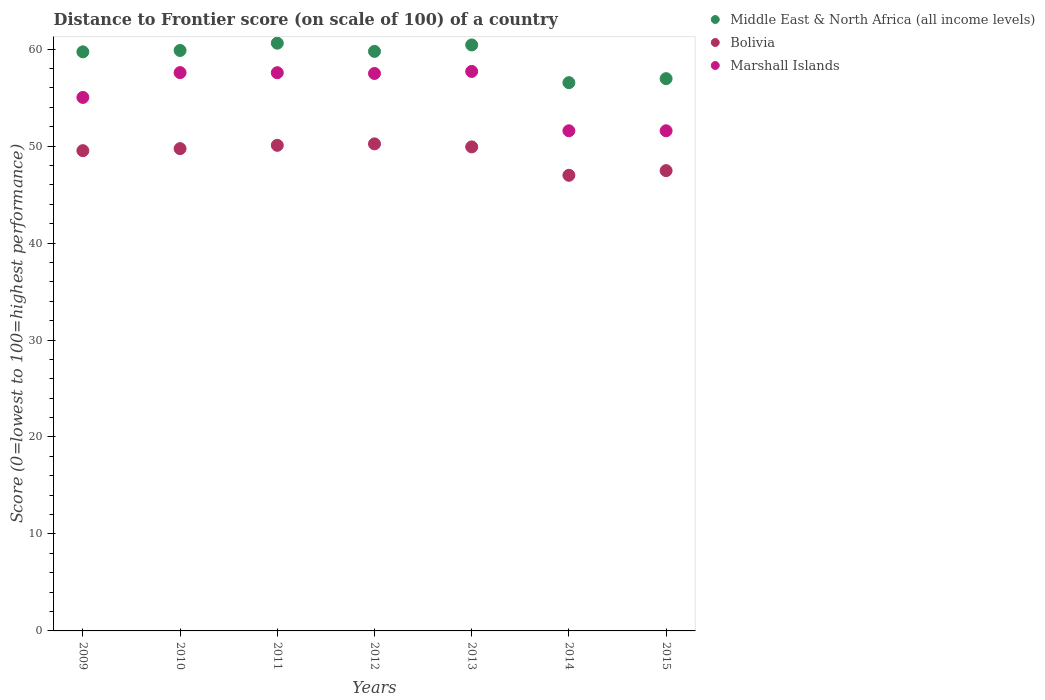What is the distance to frontier score of in Middle East & North Africa (all income levels) in 2010?
Offer a very short reply. 59.86. Across all years, what is the maximum distance to frontier score of in Bolivia?
Make the answer very short. 50.23. Across all years, what is the minimum distance to frontier score of in Bolivia?
Ensure brevity in your answer.  46.99. In which year was the distance to frontier score of in Marshall Islands maximum?
Keep it short and to the point. 2013. In which year was the distance to frontier score of in Bolivia minimum?
Keep it short and to the point. 2014. What is the total distance to frontier score of in Middle East & North Africa (all income levels) in the graph?
Your response must be concise. 413.9. What is the difference between the distance to frontier score of in Middle East & North Africa (all income levels) in 2010 and that in 2014?
Keep it short and to the point. 3.32. What is the difference between the distance to frontier score of in Middle East & North Africa (all income levels) in 2014 and the distance to frontier score of in Bolivia in 2010?
Offer a very short reply. 6.8. What is the average distance to frontier score of in Marshall Islands per year?
Your response must be concise. 55.5. In the year 2010, what is the difference between the distance to frontier score of in Marshall Islands and distance to frontier score of in Middle East & North Africa (all income levels)?
Your answer should be compact. -2.28. In how many years, is the distance to frontier score of in Bolivia greater than 38?
Provide a short and direct response. 7. What is the ratio of the distance to frontier score of in Bolivia in 2010 to that in 2015?
Your answer should be very brief. 1.05. What is the difference between the highest and the second highest distance to frontier score of in Marshall Islands?
Offer a terse response. 0.12. What is the difference between the highest and the lowest distance to frontier score of in Middle East & North Africa (all income levels)?
Provide a succinct answer. 4.07. In how many years, is the distance to frontier score of in Bolivia greater than the average distance to frontier score of in Bolivia taken over all years?
Provide a short and direct response. 5. Is it the case that in every year, the sum of the distance to frontier score of in Bolivia and distance to frontier score of in Middle East & North Africa (all income levels)  is greater than the distance to frontier score of in Marshall Islands?
Your response must be concise. Yes. How many years are there in the graph?
Make the answer very short. 7. What is the difference between two consecutive major ticks on the Y-axis?
Your answer should be very brief. 10. Does the graph contain grids?
Your response must be concise. No. Where does the legend appear in the graph?
Offer a very short reply. Top right. How are the legend labels stacked?
Your answer should be compact. Vertical. What is the title of the graph?
Provide a short and direct response. Distance to Frontier score (on scale of 100) of a country. What is the label or title of the X-axis?
Provide a succinct answer. Years. What is the label or title of the Y-axis?
Your response must be concise. Score (0=lowest to 100=highest performance). What is the Score (0=lowest to 100=highest performance) of Middle East & North Africa (all income levels) in 2009?
Keep it short and to the point. 59.72. What is the Score (0=lowest to 100=highest performance) of Bolivia in 2009?
Your answer should be compact. 49.53. What is the Score (0=lowest to 100=highest performance) of Marshall Islands in 2009?
Provide a short and direct response. 55.02. What is the Score (0=lowest to 100=highest performance) of Middle East & North Africa (all income levels) in 2010?
Offer a very short reply. 59.86. What is the Score (0=lowest to 100=highest performance) in Bolivia in 2010?
Make the answer very short. 49.74. What is the Score (0=lowest to 100=highest performance) of Marshall Islands in 2010?
Provide a short and direct response. 57.58. What is the Score (0=lowest to 100=highest performance) of Middle East & North Africa (all income levels) in 2011?
Your response must be concise. 60.61. What is the Score (0=lowest to 100=highest performance) in Bolivia in 2011?
Provide a succinct answer. 50.08. What is the Score (0=lowest to 100=highest performance) in Marshall Islands in 2011?
Offer a terse response. 57.57. What is the Score (0=lowest to 100=highest performance) in Middle East & North Africa (all income levels) in 2012?
Your answer should be compact. 59.77. What is the Score (0=lowest to 100=highest performance) of Bolivia in 2012?
Your answer should be compact. 50.23. What is the Score (0=lowest to 100=highest performance) in Marshall Islands in 2012?
Provide a short and direct response. 57.49. What is the Score (0=lowest to 100=highest performance) of Middle East & North Africa (all income levels) in 2013?
Your answer should be compact. 60.43. What is the Score (0=lowest to 100=highest performance) of Bolivia in 2013?
Give a very brief answer. 49.92. What is the Score (0=lowest to 100=highest performance) of Marshall Islands in 2013?
Offer a very short reply. 57.7. What is the Score (0=lowest to 100=highest performance) of Middle East & North Africa (all income levels) in 2014?
Keep it short and to the point. 56.54. What is the Score (0=lowest to 100=highest performance) of Bolivia in 2014?
Your answer should be very brief. 46.99. What is the Score (0=lowest to 100=highest performance) in Marshall Islands in 2014?
Offer a terse response. 51.58. What is the Score (0=lowest to 100=highest performance) of Middle East & North Africa (all income levels) in 2015?
Your answer should be compact. 56.96. What is the Score (0=lowest to 100=highest performance) in Bolivia in 2015?
Make the answer very short. 47.47. What is the Score (0=lowest to 100=highest performance) of Marshall Islands in 2015?
Give a very brief answer. 51.58. Across all years, what is the maximum Score (0=lowest to 100=highest performance) of Middle East & North Africa (all income levels)?
Offer a terse response. 60.61. Across all years, what is the maximum Score (0=lowest to 100=highest performance) in Bolivia?
Provide a succinct answer. 50.23. Across all years, what is the maximum Score (0=lowest to 100=highest performance) in Marshall Islands?
Offer a very short reply. 57.7. Across all years, what is the minimum Score (0=lowest to 100=highest performance) of Middle East & North Africa (all income levels)?
Keep it short and to the point. 56.54. Across all years, what is the minimum Score (0=lowest to 100=highest performance) in Bolivia?
Offer a very short reply. 46.99. Across all years, what is the minimum Score (0=lowest to 100=highest performance) of Marshall Islands?
Give a very brief answer. 51.58. What is the total Score (0=lowest to 100=highest performance) in Middle East & North Africa (all income levels) in the graph?
Your response must be concise. 413.9. What is the total Score (0=lowest to 100=highest performance) in Bolivia in the graph?
Provide a short and direct response. 343.96. What is the total Score (0=lowest to 100=highest performance) in Marshall Islands in the graph?
Your answer should be very brief. 388.52. What is the difference between the Score (0=lowest to 100=highest performance) of Middle East & North Africa (all income levels) in 2009 and that in 2010?
Give a very brief answer. -0.14. What is the difference between the Score (0=lowest to 100=highest performance) in Bolivia in 2009 and that in 2010?
Give a very brief answer. -0.21. What is the difference between the Score (0=lowest to 100=highest performance) of Marshall Islands in 2009 and that in 2010?
Your answer should be compact. -2.56. What is the difference between the Score (0=lowest to 100=highest performance) in Middle East & North Africa (all income levels) in 2009 and that in 2011?
Offer a very short reply. -0.9. What is the difference between the Score (0=lowest to 100=highest performance) in Bolivia in 2009 and that in 2011?
Offer a terse response. -0.55. What is the difference between the Score (0=lowest to 100=highest performance) in Marshall Islands in 2009 and that in 2011?
Give a very brief answer. -2.55. What is the difference between the Score (0=lowest to 100=highest performance) of Middle East & North Africa (all income levels) in 2009 and that in 2012?
Provide a short and direct response. -0.05. What is the difference between the Score (0=lowest to 100=highest performance) in Bolivia in 2009 and that in 2012?
Keep it short and to the point. -0.7. What is the difference between the Score (0=lowest to 100=highest performance) in Marshall Islands in 2009 and that in 2012?
Provide a short and direct response. -2.47. What is the difference between the Score (0=lowest to 100=highest performance) in Middle East & North Africa (all income levels) in 2009 and that in 2013?
Provide a short and direct response. -0.71. What is the difference between the Score (0=lowest to 100=highest performance) in Bolivia in 2009 and that in 2013?
Provide a short and direct response. -0.39. What is the difference between the Score (0=lowest to 100=highest performance) in Marshall Islands in 2009 and that in 2013?
Provide a succinct answer. -2.68. What is the difference between the Score (0=lowest to 100=highest performance) of Middle East & North Africa (all income levels) in 2009 and that in 2014?
Offer a terse response. 3.17. What is the difference between the Score (0=lowest to 100=highest performance) of Bolivia in 2009 and that in 2014?
Keep it short and to the point. 2.54. What is the difference between the Score (0=lowest to 100=highest performance) in Marshall Islands in 2009 and that in 2014?
Keep it short and to the point. 3.44. What is the difference between the Score (0=lowest to 100=highest performance) in Middle East & North Africa (all income levels) in 2009 and that in 2015?
Offer a terse response. 2.76. What is the difference between the Score (0=lowest to 100=highest performance) of Bolivia in 2009 and that in 2015?
Provide a short and direct response. 2.06. What is the difference between the Score (0=lowest to 100=highest performance) of Marshall Islands in 2009 and that in 2015?
Keep it short and to the point. 3.44. What is the difference between the Score (0=lowest to 100=highest performance) in Middle East & North Africa (all income levels) in 2010 and that in 2011?
Your answer should be compact. -0.75. What is the difference between the Score (0=lowest to 100=highest performance) of Bolivia in 2010 and that in 2011?
Ensure brevity in your answer.  -0.34. What is the difference between the Score (0=lowest to 100=highest performance) of Marshall Islands in 2010 and that in 2011?
Make the answer very short. 0.01. What is the difference between the Score (0=lowest to 100=highest performance) in Middle East & North Africa (all income levels) in 2010 and that in 2012?
Keep it short and to the point. 0.1. What is the difference between the Score (0=lowest to 100=highest performance) of Bolivia in 2010 and that in 2012?
Provide a succinct answer. -0.49. What is the difference between the Score (0=lowest to 100=highest performance) in Marshall Islands in 2010 and that in 2012?
Give a very brief answer. 0.09. What is the difference between the Score (0=lowest to 100=highest performance) in Middle East & North Africa (all income levels) in 2010 and that in 2013?
Offer a very short reply. -0.57. What is the difference between the Score (0=lowest to 100=highest performance) of Bolivia in 2010 and that in 2013?
Keep it short and to the point. -0.18. What is the difference between the Score (0=lowest to 100=highest performance) of Marshall Islands in 2010 and that in 2013?
Give a very brief answer. -0.12. What is the difference between the Score (0=lowest to 100=highest performance) in Middle East & North Africa (all income levels) in 2010 and that in 2014?
Keep it short and to the point. 3.32. What is the difference between the Score (0=lowest to 100=highest performance) of Bolivia in 2010 and that in 2014?
Provide a short and direct response. 2.75. What is the difference between the Score (0=lowest to 100=highest performance) in Middle East & North Africa (all income levels) in 2010 and that in 2015?
Your answer should be very brief. 2.91. What is the difference between the Score (0=lowest to 100=highest performance) of Bolivia in 2010 and that in 2015?
Your answer should be very brief. 2.27. What is the difference between the Score (0=lowest to 100=highest performance) in Middle East & North Africa (all income levels) in 2011 and that in 2012?
Provide a succinct answer. 0.85. What is the difference between the Score (0=lowest to 100=highest performance) of Marshall Islands in 2011 and that in 2012?
Your answer should be compact. 0.08. What is the difference between the Score (0=lowest to 100=highest performance) in Middle East & North Africa (all income levels) in 2011 and that in 2013?
Ensure brevity in your answer.  0.18. What is the difference between the Score (0=lowest to 100=highest performance) in Bolivia in 2011 and that in 2013?
Your answer should be very brief. 0.16. What is the difference between the Score (0=lowest to 100=highest performance) in Marshall Islands in 2011 and that in 2013?
Provide a succinct answer. -0.13. What is the difference between the Score (0=lowest to 100=highest performance) of Middle East & North Africa (all income levels) in 2011 and that in 2014?
Provide a short and direct response. 4.07. What is the difference between the Score (0=lowest to 100=highest performance) of Bolivia in 2011 and that in 2014?
Your answer should be compact. 3.09. What is the difference between the Score (0=lowest to 100=highest performance) in Marshall Islands in 2011 and that in 2014?
Ensure brevity in your answer.  5.99. What is the difference between the Score (0=lowest to 100=highest performance) of Middle East & North Africa (all income levels) in 2011 and that in 2015?
Your response must be concise. 3.66. What is the difference between the Score (0=lowest to 100=highest performance) in Bolivia in 2011 and that in 2015?
Provide a succinct answer. 2.61. What is the difference between the Score (0=lowest to 100=highest performance) in Marshall Islands in 2011 and that in 2015?
Offer a terse response. 5.99. What is the difference between the Score (0=lowest to 100=highest performance) in Middle East & North Africa (all income levels) in 2012 and that in 2013?
Your answer should be very brief. -0.67. What is the difference between the Score (0=lowest to 100=highest performance) of Bolivia in 2012 and that in 2013?
Your response must be concise. 0.31. What is the difference between the Score (0=lowest to 100=highest performance) in Marshall Islands in 2012 and that in 2013?
Your answer should be compact. -0.21. What is the difference between the Score (0=lowest to 100=highest performance) of Middle East & North Africa (all income levels) in 2012 and that in 2014?
Ensure brevity in your answer.  3.22. What is the difference between the Score (0=lowest to 100=highest performance) in Bolivia in 2012 and that in 2014?
Your answer should be very brief. 3.24. What is the difference between the Score (0=lowest to 100=highest performance) in Marshall Islands in 2012 and that in 2014?
Your response must be concise. 5.91. What is the difference between the Score (0=lowest to 100=highest performance) in Middle East & North Africa (all income levels) in 2012 and that in 2015?
Offer a terse response. 2.81. What is the difference between the Score (0=lowest to 100=highest performance) of Bolivia in 2012 and that in 2015?
Keep it short and to the point. 2.76. What is the difference between the Score (0=lowest to 100=highest performance) of Marshall Islands in 2012 and that in 2015?
Offer a terse response. 5.91. What is the difference between the Score (0=lowest to 100=highest performance) in Middle East & North Africa (all income levels) in 2013 and that in 2014?
Your answer should be very brief. 3.89. What is the difference between the Score (0=lowest to 100=highest performance) in Bolivia in 2013 and that in 2014?
Your answer should be very brief. 2.93. What is the difference between the Score (0=lowest to 100=highest performance) in Marshall Islands in 2013 and that in 2014?
Provide a succinct answer. 6.12. What is the difference between the Score (0=lowest to 100=highest performance) in Middle East & North Africa (all income levels) in 2013 and that in 2015?
Give a very brief answer. 3.48. What is the difference between the Score (0=lowest to 100=highest performance) in Bolivia in 2013 and that in 2015?
Offer a very short reply. 2.45. What is the difference between the Score (0=lowest to 100=highest performance) of Marshall Islands in 2013 and that in 2015?
Give a very brief answer. 6.12. What is the difference between the Score (0=lowest to 100=highest performance) of Middle East & North Africa (all income levels) in 2014 and that in 2015?
Provide a short and direct response. -0.41. What is the difference between the Score (0=lowest to 100=highest performance) in Bolivia in 2014 and that in 2015?
Keep it short and to the point. -0.48. What is the difference between the Score (0=lowest to 100=highest performance) of Marshall Islands in 2014 and that in 2015?
Provide a succinct answer. 0. What is the difference between the Score (0=lowest to 100=highest performance) of Middle East & North Africa (all income levels) in 2009 and the Score (0=lowest to 100=highest performance) of Bolivia in 2010?
Keep it short and to the point. 9.98. What is the difference between the Score (0=lowest to 100=highest performance) in Middle East & North Africa (all income levels) in 2009 and the Score (0=lowest to 100=highest performance) in Marshall Islands in 2010?
Offer a very short reply. 2.14. What is the difference between the Score (0=lowest to 100=highest performance) of Bolivia in 2009 and the Score (0=lowest to 100=highest performance) of Marshall Islands in 2010?
Your response must be concise. -8.05. What is the difference between the Score (0=lowest to 100=highest performance) of Middle East & North Africa (all income levels) in 2009 and the Score (0=lowest to 100=highest performance) of Bolivia in 2011?
Your answer should be compact. 9.64. What is the difference between the Score (0=lowest to 100=highest performance) of Middle East & North Africa (all income levels) in 2009 and the Score (0=lowest to 100=highest performance) of Marshall Islands in 2011?
Make the answer very short. 2.15. What is the difference between the Score (0=lowest to 100=highest performance) in Bolivia in 2009 and the Score (0=lowest to 100=highest performance) in Marshall Islands in 2011?
Your answer should be compact. -8.04. What is the difference between the Score (0=lowest to 100=highest performance) of Middle East & North Africa (all income levels) in 2009 and the Score (0=lowest to 100=highest performance) of Bolivia in 2012?
Your response must be concise. 9.49. What is the difference between the Score (0=lowest to 100=highest performance) of Middle East & North Africa (all income levels) in 2009 and the Score (0=lowest to 100=highest performance) of Marshall Islands in 2012?
Provide a short and direct response. 2.23. What is the difference between the Score (0=lowest to 100=highest performance) in Bolivia in 2009 and the Score (0=lowest to 100=highest performance) in Marshall Islands in 2012?
Provide a short and direct response. -7.96. What is the difference between the Score (0=lowest to 100=highest performance) of Middle East & North Africa (all income levels) in 2009 and the Score (0=lowest to 100=highest performance) of Bolivia in 2013?
Make the answer very short. 9.8. What is the difference between the Score (0=lowest to 100=highest performance) of Middle East & North Africa (all income levels) in 2009 and the Score (0=lowest to 100=highest performance) of Marshall Islands in 2013?
Provide a short and direct response. 2.02. What is the difference between the Score (0=lowest to 100=highest performance) of Bolivia in 2009 and the Score (0=lowest to 100=highest performance) of Marshall Islands in 2013?
Keep it short and to the point. -8.17. What is the difference between the Score (0=lowest to 100=highest performance) of Middle East & North Africa (all income levels) in 2009 and the Score (0=lowest to 100=highest performance) of Bolivia in 2014?
Offer a very short reply. 12.73. What is the difference between the Score (0=lowest to 100=highest performance) of Middle East & North Africa (all income levels) in 2009 and the Score (0=lowest to 100=highest performance) of Marshall Islands in 2014?
Your answer should be very brief. 8.14. What is the difference between the Score (0=lowest to 100=highest performance) of Bolivia in 2009 and the Score (0=lowest to 100=highest performance) of Marshall Islands in 2014?
Make the answer very short. -2.05. What is the difference between the Score (0=lowest to 100=highest performance) of Middle East & North Africa (all income levels) in 2009 and the Score (0=lowest to 100=highest performance) of Bolivia in 2015?
Offer a terse response. 12.25. What is the difference between the Score (0=lowest to 100=highest performance) in Middle East & North Africa (all income levels) in 2009 and the Score (0=lowest to 100=highest performance) in Marshall Islands in 2015?
Provide a short and direct response. 8.14. What is the difference between the Score (0=lowest to 100=highest performance) of Bolivia in 2009 and the Score (0=lowest to 100=highest performance) of Marshall Islands in 2015?
Your response must be concise. -2.05. What is the difference between the Score (0=lowest to 100=highest performance) of Middle East & North Africa (all income levels) in 2010 and the Score (0=lowest to 100=highest performance) of Bolivia in 2011?
Your answer should be compact. 9.78. What is the difference between the Score (0=lowest to 100=highest performance) in Middle East & North Africa (all income levels) in 2010 and the Score (0=lowest to 100=highest performance) in Marshall Islands in 2011?
Keep it short and to the point. 2.29. What is the difference between the Score (0=lowest to 100=highest performance) of Bolivia in 2010 and the Score (0=lowest to 100=highest performance) of Marshall Islands in 2011?
Keep it short and to the point. -7.83. What is the difference between the Score (0=lowest to 100=highest performance) of Middle East & North Africa (all income levels) in 2010 and the Score (0=lowest to 100=highest performance) of Bolivia in 2012?
Your answer should be compact. 9.63. What is the difference between the Score (0=lowest to 100=highest performance) of Middle East & North Africa (all income levels) in 2010 and the Score (0=lowest to 100=highest performance) of Marshall Islands in 2012?
Offer a terse response. 2.37. What is the difference between the Score (0=lowest to 100=highest performance) in Bolivia in 2010 and the Score (0=lowest to 100=highest performance) in Marshall Islands in 2012?
Provide a short and direct response. -7.75. What is the difference between the Score (0=lowest to 100=highest performance) of Middle East & North Africa (all income levels) in 2010 and the Score (0=lowest to 100=highest performance) of Bolivia in 2013?
Keep it short and to the point. 9.94. What is the difference between the Score (0=lowest to 100=highest performance) in Middle East & North Africa (all income levels) in 2010 and the Score (0=lowest to 100=highest performance) in Marshall Islands in 2013?
Offer a terse response. 2.16. What is the difference between the Score (0=lowest to 100=highest performance) of Bolivia in 2010 and the Score (0=lowest to 100=highest performance) of Marshall Islands in 2013?
Make the answer very short. -7.96. What is the difference between the Score (0=lowest to 100=highest performance) of Middle East & North Africa (all income levels) in 2010 and the Score (0=lowest to 100=highest performance) of Bolivia in 2014?
Offer a terse response. 12.87. What is the difference between the Score (0=lowest to 100=highest performance) of Middle East & North Africa (all income levels) in 2010 and the Score (0=lowest to 100=highest performance) of Marshall Islands in 2014?
Your answer should be very brief. 8.28. What is the difference between the Score (0=lowest to 100=highest performance) in Bolivia in 2010 and the Score (0=lowest to 100=highest performance) in Marshall Islands in 2014?
Keep it short and to the point. -1.84. What is the difference between the Score (0=lowest to 100=highest performance) in Middle East & North Africa (all income levels) in 2010 and the Score (0=lowest to 100=highest performance) in Bolivia in 2015?
Give a very brief answer. 12.39. What is the difference between the Score (0=lowest to 100=highest performance) of Middle East & North Africa (all income levels) in 2010 and the Score (0=lowest to 100=highest performance) of Marshall Islands in 2015?
Offer a very short reply. 8.28. What is the difference between the Score (0=lowest to 100=highest performance) of Bolivia in 2010 and the Score (0=lowest to 100=highest performance) of Marshall Islands in 2015?
Your answer should be compact. -1.84. What is the difference between the Score (0=lowest to 100=highest performance) in Middle East & North Africa (all income levels) in 2011 and the Score (0=lowest to 100=highest performance) in Bolivia in 2012?
Provide a short and direct response. 10.38. What is the difference between the Score (0=lowest to 100=highest performance) of Middle East & North Africa (all income levels) in 2011 and the Score (0=lowest to 100=highest performance) of Marshall Islands in 2012?
Provide a short and direct response. 3.12. What is the difference between the Score (0=lowest to 100=highest performance) in Bolivia in 2011 and the Score (0=lowest to 100=highest performance) in Marshall Islands in 2012?
Offer a terse response. -7.41. What is the difference between the Score (0=lowest to 100=highest performance) of Middle East & North Africa (all income levels) in 2011 and the Score (0=lowest to 100=highest performance) of Bolivia in 2013?
Your response must be concise. 10.69. What is the difference between the Score (0=lowest to 100=highest performance) of Middle East & North Africa (all income levels) in 2011 and the Score (0=lowest to 100=highest performance) of Marshall Islands in 2013?
Keep it short and to the point. 2.91. What is the difference between the Score (0=lowest to 100=highest performance) in Bolivia in 2011 and the Score (0=lowest to 100=highest performance) in Marshall Islands in 2013?
Your answer should be compact. -7.62. What is the difference between the Score (0=lowest to 100=highest performance) of Middle East & North Africa (all income levels) in 2011 and the Score (0=lowest to 100=highest performance) of Bolivia in 2014?
Make the answer very short. 13.62. What is the difference between the Score (0=lowest to 100=highest performance) in Middle East & North Africa (all income levels) in 2011 and the Score (0=lowest to 100=highest performance) in Marshall Islands in 2014?
Your answer should be very brief. 9.03. What is the difference between the Score (0=lowest to 100=highest performance) in Middle East & North Africa (all income levels) in 2011 and the Score (0=lowest to 100=highest performance) in Bolivia in 2015?
Give a very brief answer. 13.14. What is the difference between the Score (0=lowest to 100=highest performance) in Middle East & North Africa (all income levels) in 2011 and the Score (0=lowest to 100=highest performance) in Marshall Islands in 2015?
Offer a very short reply. 9.03. What is the difference between the Score (0=lowest to 100=highest performance) in Middle East & North Africa (all income levels) in 2012 and the Score (0=lowest to 100=highest performance) in Bolivia in 2013?
Your answer should be very brief. 9.85. What is the difference between the Score (0=lowest to 100=highest performance) of Middle East & North Africa (all income levels) in 2012 and the Score (0=lowest to 100=highest performance) of Marshall Islands in 2013?
Offer a terse response. 2.07. What is the difference between the Score (0=lowest to 100=highest performance) in Bolivia in 2012 and the Score (0=lowest to 100=highest performance) in Marshall Islands in 2013?
Give a very brief answer. -7.47. What is the difference between the Score (0=lowest to 100=highest performance) of Middle East & North Africa (all income levels) in 2012 and the Score (0=lowest to 100=highest performance) of Bolivia in 2014?
Your response must be concise. 12.78. What is the difference between the Score (0=lowest to 100=highest performance) in Middle East & North Africa (all income levels) in 2012 and the Score (0=lowest to 100=highest performance) in Marshall Islands in 2014?
Your answer should be compact. 8.19. What is the difference between the Score (0=lowest to 100=highest performance) in Bolivia in 2012 and the Score (0=lowest to 100=highest performance) in Marshall Islands in 2014?
Provide a succinct answer. -1.35. What is the difference between the Score (0=lowest to 100=highest performance) in Middle East & North Africa (all income levels) in 2012 and the Score (0=lowest to 100=highest performance) in Bolivia in 2015?
Provide a short and direct response. 12.3. What is the difference between the Score (0=lowest to 100=highest performance) of Middle East & North Africa (all income levels) in 2012 and the Score (0=lowest to 100=highest performance) of Marshall Islands in 2015?
Keep it short and to the point. 8.19. What is the difference between the Score (0=lowest to 100=highest performance) in Bolivia in 2012 and the Score (0=lowest to 100=highest performance) in Marshall Islands in 2015?
Provide a succinct answer. -1.35. What is the difference between the Score (0=lowest to 100=highest performance) in Middle East & North Africa (all income levels) in 2013 and the Score (0=lowest to 100=highest performance) in Bolivia in 2014?
Your answer should be compact. 13.44. What is the difference between the Score (0=lowest to 100=highest performance) in Middle East & North Africa (all income levels) in 2013 and the Score (0=lowest to 100=highest performance) in Marshall Islands in 2014?
Give a very brief answer. 8.85. What is the difference between the Score (0=lowest to 100=highest performance) of Bolivia in 2013 and the Score (0=lowest to 100=highest performance) of Marshall Islands in 2014?
Your answer should be compact. -1.66. What is the difference between the Score (0=lowest to 100=highest performance) in Middle East & North Africa (all income levels) in 2013 and the Score (0=lowest to 100=highest performance) in Bolivia in 2015?
Provide a succinct answer. 12.96. What is the difference between the Score (0=lowest to 100=highest performance) in Middle East & North Africa (all income levels) in 2013 and the Score (0=lowest to 100=highest performance) in Marshall Islands in 2015?
Make the answer very short. 8.85. What is the difference between the Score (0=lowest to 100=highest performance) in Bolivia in 2013 and the Score (0=lowest to 100=highest performance) in Marshall Islands in 2015?
Your response must be concise. -1.66. What is the difference between the Score (0=lowest to 100=highest performance) in Middle East & North Africa (all income levels) in 2014 and the Score (0=lowest to 100=highest performance) in Bolivia in 2015?
Give a very brief answer. 9.07. What is the difference between the Score (0=lowest to 100=highest performance) of Middle East & North Africa (all income levels) in 2014 and the Score (0=lowest to 100=highest performance) of Marshall Islands in 2015?
Keep it short and to the point. 4.96. What is the difference between the Score (0=lowest to 100=highest performance) of Bolivia in 2014 and the Score (0=lowest to 100=highest performance) of Marshall Islands in 2015?
Make the answer very short. -4.59. What is the average Score (0=lowest to 100=highest performance) of Middle East & North Africa (all income levels) per year?
Your answer should be very brief. 59.13. What is the average Score (0=lowest to 100=highest performance) of Bolivia per year?
Give a very brief answer. 49.14. What is the average Score (0=lowest to 100=highest performance) of Marshall Islands per year?
Ensure brevity in your answer.  55.5. In the year 2009, what is the difference between the Score (0=lowest to 100=highest performance) in Middle East & North Africa (all income levels) and Score (0=lowest to 100=highest performance) in Bolivia?
Give a very brief answer. 10.19. In the year 2009, what is the difference between the Score (0=lowest to 100=highest performance) in Middle East & North Africa (all income levels) and Score (0=lowest to 100=highest performance) in Marshall Islands?
Your answer should be compact. 4.7. In the year 2009, what is the difference between the Score (0=lowest to 100=highest performance) in Bolivia and Score (0=lowest to 100=highest performance) in Marshall Islands?
Keep it short and to the point. -5.49. In the year 2010, what is the difference between the Score (0=lowest to 100=highest performance) in Middle East & North Africa (all income levels) and Score (0=lowest to 100=highest performance) in Bolivia?
Offer a terse response. 10.12. In the year 2010, what is the difference between the Score (0=lowest to 100=highest performance) of Middle East & North Africa (all income levels) and Score (0=lowest to 100=highest performance) of Marshall Islands?
Your answer should be very brief. 2.28. In the year 2010, what is the difference between the Score (0=lowest to 100=highest performance) of Bolivia and Score (0=lowest to 100=highest performance) of Marshall Islands?
Give a very brief answer. -7.84. In the year 2011, what is the difference between the Score (0=lowest to 100=highest performance) in Middle East & North Africa (all income levels) and Score (0=lowest to 100=highest performance) in Bolivia?
Your answer should be very brief. 10.53. In the year 2011, what is the difference between the Score (0=lowest to 100=highest performance) in Middle East & North Africa (all income levels) and Score (0=lowest to 100=highest performance) in Marshall Islands?
Keep it short and to the point. 3.04. In the year 2011, what is the difference between the Score (0=lowest to 100=highest performance) of Bolivia and Score (0=lowest to 100=highest performance) of Marshall Islands?
Your answer should be compact. -7.49. In the year 2012, what is the difference between the Score (0=lowest to 100=highest performance) of Middle East & North Africa (all income levels) and Score (0=lowest to 100=highest performance) of Bolivia?
Keep it short and to the point. 9.54. In the year 2012, what is the difference between the Score (0=lowest to 100=highest performance) in Middle East & North Africa (all income levels) and Score (0=lowest to 100=highest performance) in Marshall Islands?
Provide a succinct answer. 2.28. In the year 2012, what is the difference between the Score (0=lowest to 100=highest performance) of Bolivia and Score (0=lowest to 100=highest performance) of Marshall Islands?
Your answer should be very brief. -7.26. In the year 2013, what is the difference between the Score (0=lowest to 100=highest performance) of Middle East & North Africa (all income levels) and Score (0=lowest to 100=highest performance) of Bolivia?
Keep it short and to the point. 10.51. In the year 2013, what is the difference between the Score (0=lowest to 100=highest performance) in Middle East & North Africa (all income levels) and Score (0=lowest to 100=highest performance) in Marshall Islands?
Offer a terse response. 2.73. In the year 2013, what is the difference between the Score (0=lowest to 100=highest performance) of Bolivia and Score (0=lowest to 100=highest performance) of Marshall Islands?
Your answer should be compact. -7.78. In the year 2014, what is the difference between the Score (0=lowest to 100=highest performance) of Middle East & North Africa (all income levels) and Score (0=lowest to 100=highest performance) of Bolivia?
Your answer should be compact. 9.55. In the year 2014, what is the difference between the Score (0=lowest to 100=highest performance) of Middle East & North Africa (all income levels) and Score (0=lowest to 100=highest performance) of Marshall Islands?
Your response must be concise. 4.96. In the year 2014, what is the difference between the Score (0=lowest to 100=highest performance) of Bolivia and Score (0=lowest to 100=highest performance) of Marshall Islands?
Keep it short and to the point. -4.59. In the year 2015, what is the difference between the Score (0=lowest to 100=highest performance) of Middle East & North Africa (all income levels) and Score (0=lowest to 100=highest performance) of Bolivia?
Your answer should be compact. 9.49. In the year 2015, what is the difference between the Score (0=lowest to 100=highest performance) of Middle East & North Africa (all income levels) and Score (0=lowest to 100=highest performance) of Marshall Islands?
Provide a short and direct response. 5.38. In the year 2015, what is the difference between the Score (0=lowest to 100=highest performance) of Bolivia and Score (0=lowest to 100=highest performance) of Marshall Islands?
Provide a succinct answer. -4.11. What is the ratio of the Score (0=lowest to 100=highest performance) in Middle East & North Africa (all income levels) in 2009 to that in 2010?
Offer a very short reply. 1. What is the ratio of the Score (0=lowest to 100=highest performance) in Bolivia in 2009 to that in 2010?
Your response must be concise. 1. What is the ratio of the Score (0=lowest to 100=highest performance) in Marshall Islands in 2009 to that in 2010?
Make the answer very short. 0.96. What is the ratio of the Score (0=lowest to 100=highest performance) of Middle East & North Africa (all income levels) in 2009 to that in 2011?
Your answer should be compact. 0.99. What is the ratio of the Score (0=lowest to 100=highest performance) of Bolivia in 2009 to that in 2011?
Your answer should be compact. 0.99. What is the ratio of the Score (0=lowest to 100=highest performance) in Marshall Islands in 2009 to that in 2011?
Ensure brevity in your answer.  0.96. What is the ratio of the Score (0=lowest to 100=highest performance) in Middle East & North Africa (all income levels) in 2009 to that in 2012?
Give a very brief answer. 1. What is the ratio of the Score (0=lowest to 100=highest performance) of Bolivia in 2009 to that in 2012?
Provide a succinct answer. 0.99. What is the ratio of the Score (0=lowest to 100=highest performance) of Bolivia in 2009 to that in 2013?
Keep it short and to the point. 0.99. What is the ratio of the Score (0=lowest to 100=highest performance) in Marshall Islands in 2009 to that in 2013?
Your answer should be very brief. 0.95. What is the ratio of the Score (0=lowest to 100=highest performance) of Middle East & North Africa (all income levels) in 2009 to that in 2014?
Offer a terse response. 1.06. What is the ratio of the Score (0=lowest to 100=highest performance) in Bolivia in 2009 to that in 2014?
Make the answer very short. 1.05. What is the ratio of the Score (0=lowest to 100=highest performance) in Marshall Islands in 2009 to that in 2014?
Your answer should be compact. 1.07. What is the ratio of the Score (0=lowest to 100=highest performance) of Middle East & North Africa (all income levels) in 2009 to that in 2015?
Provide a succinct answer. 1.05. What is the ratio of the Score (0=lowest to 100=highest performance) of Bolivia in 2009 to that in 2015?
Your response must be concise. 1.04. What is the ratio of the Score (0=lowest to 100=highest performance) in Marshall Islands in 2009 to that in 2015?
Offer a very short reply. 1.07. What is the ratio of the Score (0=lowest to 100=highest performance) in Middle East & North Africa (all income levels) in 2010 to that in 2011?
Provide a succinct answer. 0.99. What is the ratio of the Score (0=lowest to 100=highest performance) in Bolivia in 2010 to that in 2011?
Give a very brief answer. 0.99. What is the ratio of the Score (0=lowest to 100=highest performance) in Middle East & North Africa (all income levels) in 2010 to that in 2012?
Give a very brief answer. 1. What is the ratio of the Score (0=lowest to 100=highest performance) of Bolivia in 2010 to that in 2012?
Provide a short and direct response. 0.99. What is the ratio of the Score (0=lowest to 100=highest performance) in Middle East & North Africa (all income levels) in 2010 to that in 2013?
Give a very brief answer. 0.99. What is the ratio of the Score (0=lowest to 100=highest performance) of Middle East & North Africa (all income levels) in 2010 to that in 2014?
Offer a terse response. 1.06. What is the ratio of the Score (0=lowest to 100=highest performance) of Bolivia in 2010 to that in 2014?
Make the answer very short. 1.06. What is the ratio of the Score (0=lowest to 100=highest performance) of Marshall Islands in 2010 to that in 2014?
Provide a short and direct response. 1.12. What is the ratio of the Score (0=lowest to 100=highest performance) in Middle East & North Africa (all income levels) in 2010 to that in 2015?
Offer a very short reply. 1.05. What is the ratio of the Score (0=lowest to 100=highest performance) of Bolivia in 2010 to that in 2015?
Offer a very short reply. 1.05. What is the ratio of the Score (0=lowest to 100=highest performance) in Marshall Islands in 2010 to that in 2015?
Your answer should be very brief. 1.12. What is the ratio of the Score (0=lowest to 100=highest performance) in Middle East & North Africa (all income levels) in 2011 to that in 2012?
Provide a succinct answer. 1.01. What is the ratio of the Score (0=lowest to 100=highest performance) of Middle East & North Africa (all income levels) in 2011 to that in 2013?
Your answer should be very brief. 1. What is the ratio of the Score (0=lowest to 100=highest performance) of Marshall Islands in 2011 to that in 2013?
Offer a terse response. 1. What is the ratio of the Score (0=lowest to 100=highest performance) in Middle East & North Africa (all income levels) in 2011 to that in 2014?
Keep it short and to the point. 1.07. What is the ratio of the Score (0=lowest to 100=highest performance) of Bolivia in 2011 to that in 2014?
Offer a terse response. 1.07. What is the ratio of the Score (0=lowest to 100=highest performance) of Marshall Islands in 2011 to that in 2014?
Your answer should be compact. 1.12. What is the ratio of the Score (0=lowest to 100=highest performance) in Middle East & North Africa (all income levels) in 2011 to that in 2015?
Give a very brief answer. 1.06. What is the ratio of the Score (0=lowest to 100=highest performance) of Bolivia in 2011 to that in 2015?
Offer a very short reply. 1.05. What is the ratio of the Score (0=lowest to 100=highest performance) of Marshall Islands in 2011 to that in 2015?
Offer a very short reply. 1.12. What is the ratio of the Score (0=lowest to 100=highest performance) in Middle East & North Africa (all income levels) in 2012 to that in 2013?
Provide a short and direct response. 0.99. What is the ratio of the Score (0=lowest to 100=highest performance) of Bolivia in 2012 to that in 2013?
Provide a short and direct response. 1.01. What is the ratio of the Score (0=lowest to 100=highest performance) of Middle East & North Africa (all income levels) in 2012 to that in 2014?
Provide a short and direct response. 1.06. What is the ratio of the Score (0=lowest to 100=highest performance) in Bolivia in 2012 to that in 2014?
Provide a succinct answer. 1.07. What is the ratio of the Score (0=lowest to 100=highest performance) of Marshall Islands in 2012 to that in 2014?
Ensure brevity in your answer.  1.11. What is the ratio of the Score (0=lowest to 100=highest performance) of Middle East & North Africa (all income levels) in 2012 to that in 2015?
Keep it short and to the point. 1.05. What is the ratio of the Score (0=lowest to 100=highest performance) of Bolivia in 2012 to that in 2015?
Keep it short and to the point. 1.06. What is the ratio of the Score (0=lowest to 100=highest performance) in Marshall Islands in 2012 to that in 2015?
Keep it short and to the point. 1.11. What is the ratio of the Score (0=lowest to 100=highest performance) in Middle East & North Africa (all income levels) in 2013 to that in 2014?
Make the answer very short. 1.07. What is the ratio of the Score (0=lowest to 100=highest performance) of Bolivia in 2013 to that in 2014?
Make the answer very short. 1.06. What is the ratio of the Score (0=lowest to 100=highest performance) in Marshall Islands in 2013 to that in 2014?
Keep it short and to the point. 1.12. What is the ratio of the Score (0=lowest to 100=highest performance) of Middle East & North Africa (all income levels) in 2013 to that in 2015?
Ensure brevity in your answer.  1.06. What is the ratio of the Score (0=lowest to 100=highest performance) of Bolivia in 2013 to that in 2015?
Provide a short and direct response. 1.05. What is the ratio of the Score (0=lowest to 100=highest performance) of Marshall Islands in 2013 to that in 2015?
Your answer should be very brief. 1.12. What is the difference between the highest and the second highest Score (0=lowest to 100=highest performance) in Middle East & North Africa (all income levels)?
Ensure brevity in your answer.  0.18. What is the difference between the highest and the second highest Score (0=lowest to 100=highest performance) in Bolivia?
Provide a short and direct response. 0.15. What is the difference between the highest and the second highest Score (0=lowest to 100=highest performance) of Marshall Islands?
Offer a terse response. 0.12. What is the difference between the highest and the lowest Score (0=lowest to 100=highest performance) in Middle East & North Africa (all income levels)?
Provide a succinct answer. 4.07. What is the difference between the highest and the lowest Score (0=lowest to 100=highest performance) in Bolivia?
Make the answer very short. 3.24. What is the difference between the highest and the lowest Score (0=lowest to 100=highest performance) of Marshall Islands?
Your response must be concise. 6.12. 